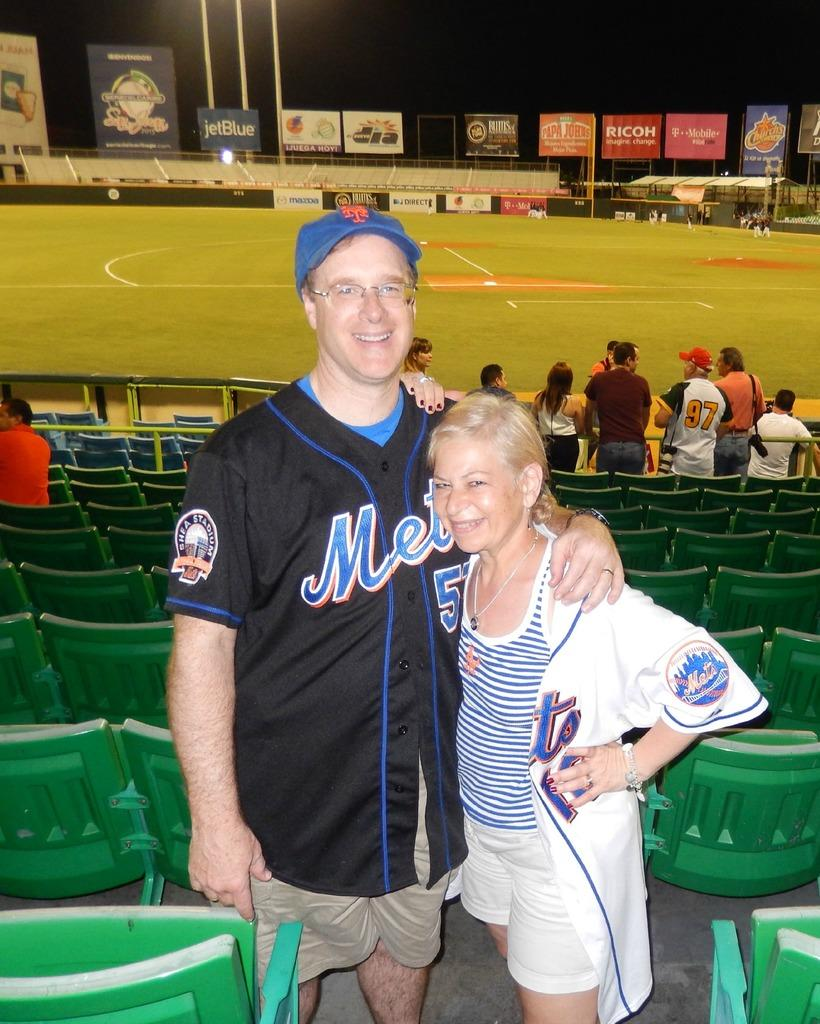Provide a one-sentence caption for the provided image. Someone at a baseball field with a black mets jersey on. 